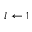<formula> <loc_0><loc_0><loc_500><loc_500>l \gets 1</formula> 